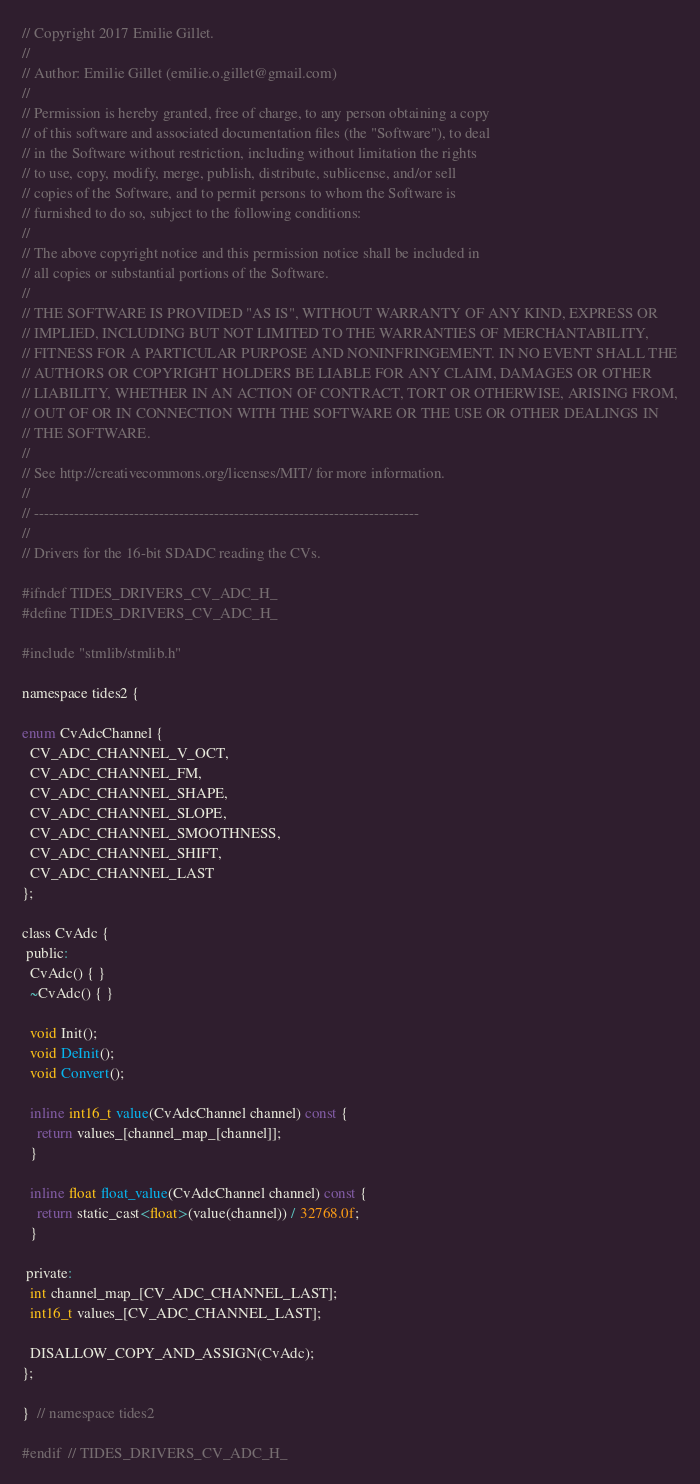Convert code to text. <code><loc_0><loc_0><loc_500><loc_500><_C_>// Copyright 2017 Emilie Gillet.
//
// Author: Emilie Gillet (emilie.o.gillet@gmail.com)
//
// Permission is hereby granted, free of charge, to any person obtaining a copy
// of this software and associated documentation files (the "Software"), to deal
// in the Software without restriction, including without limitation the rights
// to use, copy, modify, merge, publish, distribute, sublicense, and/or sell
// copies of the Software, and to permit persons to whom the Software is
// furnished to do so, subject to the following conditions:
// 
// The above copyright notice and this permission notice shall be included in
// all copies or substantial portions of the Software.
// 
// THE SOFTWARE IS PROVIDED "AS IS", WITHOUT WARRANTY OF ANY KIND, EXPRESS OR
// IMPLIED, INCLUDING BUT NOT LIMITED TO THE WARRANTIES OF MERCHANTABILITY,
// FITNESS FOR A PARTICULAR PURPOSE AND NONINFRINGEMENT. IN NO EVENT SHALL THE
// AUTHORS OR COPYRIGHT HOLDERS BE LIABLE FOR ANY CLAIM, DAMAGES OR OTHER
// LIABILITY, WHETHER IN AN ACTION OF CONTRACT, TORT OR OTHERWISE, ARISING FROM,
// OUT OF OR IN CONNECTION WITH THE SOFTWARE OR THE USE OR OTHER DEALINGS IN
// THE SOFTWARE.
// 
// See http://creativecommons.org/licenses/MIT/ for more information.
//
// -----------------------------------------------------------------------------
//
// Drivers for the 16-bit SDADC reading the CVs.

#ifndef TIDES_DRIVERS_CV_ADC_H_
#define TIDES_DRIVERS_CV_ADC_H_

#include "stmlib/stmlib.h"

namespace tides2 {

enum CvAdcChannel {
  CV_ADC_CHANNEL_V_OCT,
  CV_ADC_CHANNEL_FM,
  CV_ADC_CHANNEL_SHAPE,
  CV_ADC_CHANNEL_SLOPE,
  CV_ADC_CHANNEL_SMOOTHNESS,
  CV_ADC_CHANNEL_SHIFT,
  CV_ADC_CHANNEL_LAST
};
  
class CvAdc {
 public:
  CvAdc() { }
  ~CvAdc() { }
  
  void Init();
  void DeInit();
  void Convert();

  inline int16_t value(CvAdcChannel channel) const {
    return values_[channel_map_[channel]];
  }
  
  inline float float_value(CvAdcChannel channel) const {
    return static_cast<float>(value(channel)) / 32768.0f;
  }
  
 private:
  int channel_map_[CV_ADC_CHANNEL_LAST];
  int16_t values_[CV_ADC_CHANNEL_LAST];
  
  DISALLOW_COPY_AND_ASSIGN(CvAdc);
};

}  // namespace tides2

#endif  // TIDES_DRIVERS_CV_ADC_H_
</code> 